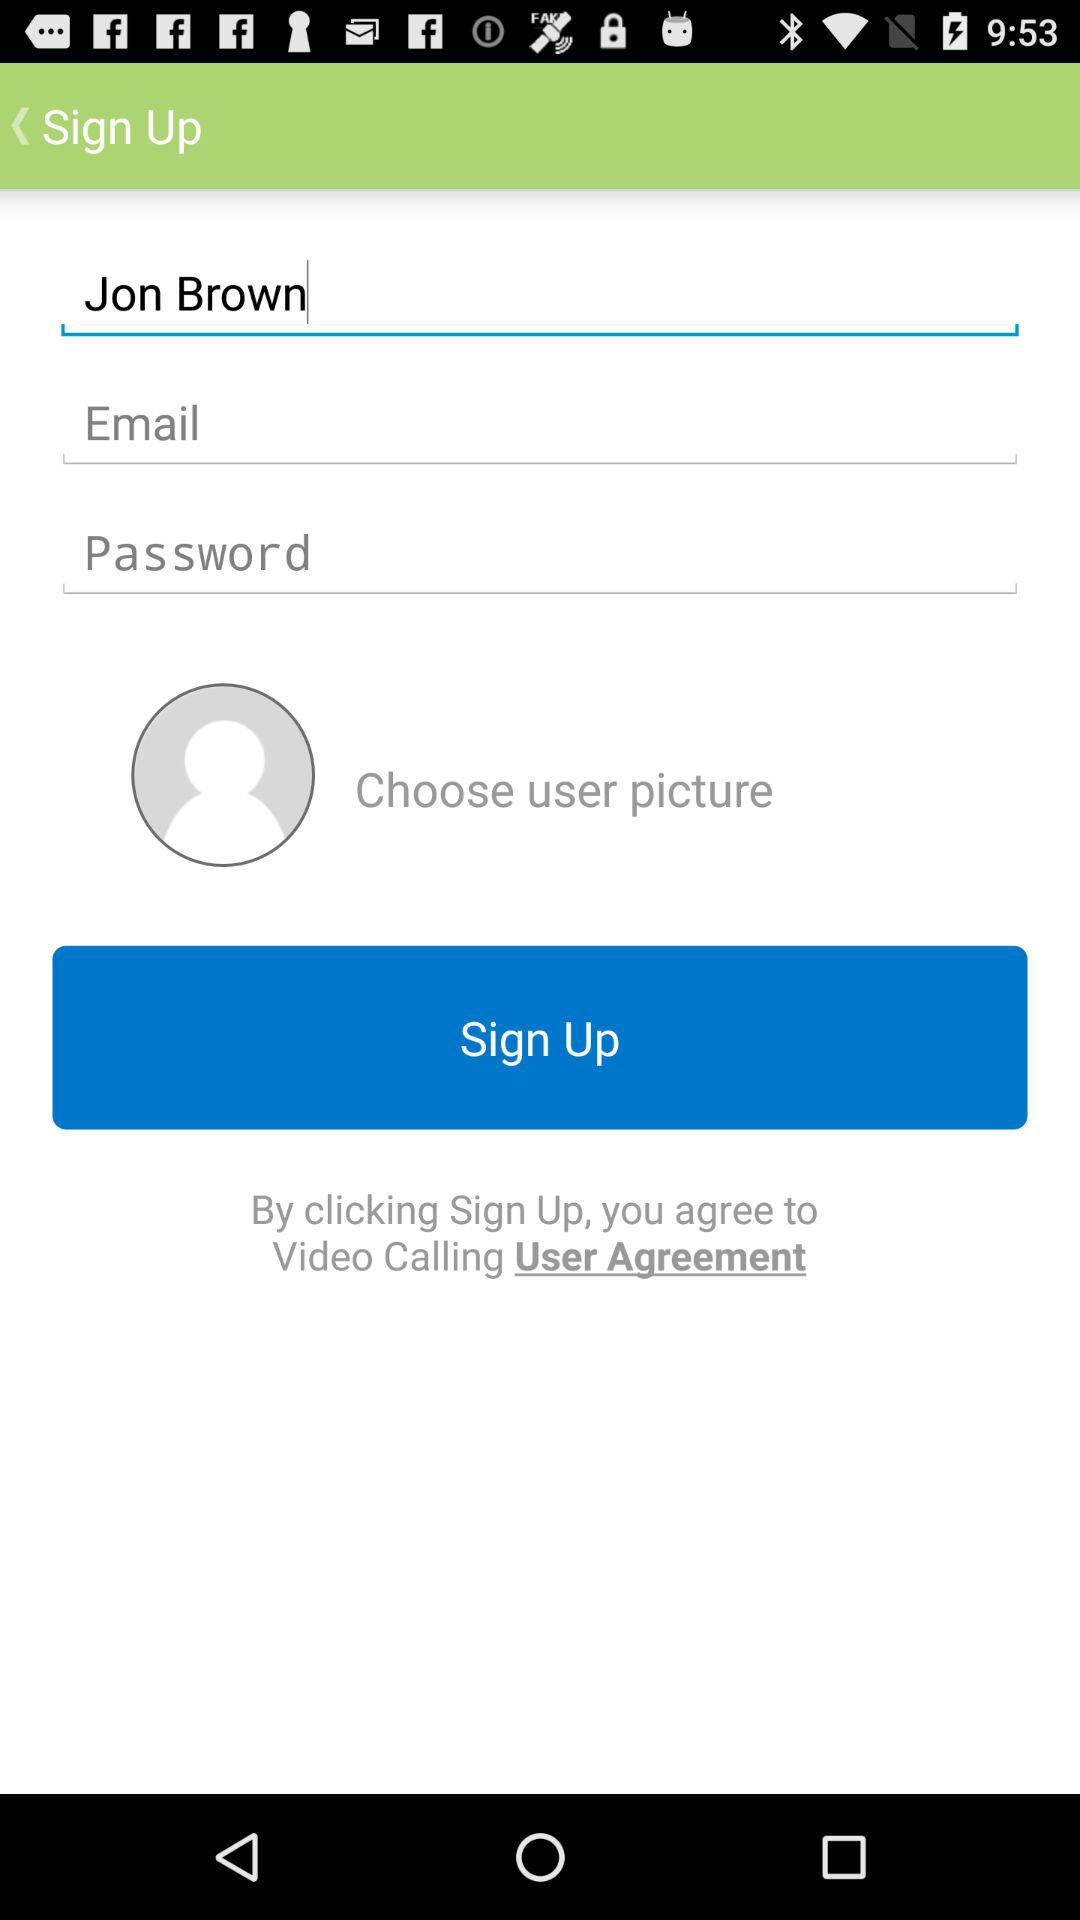What is the user name? The user name is Jon Brown. 